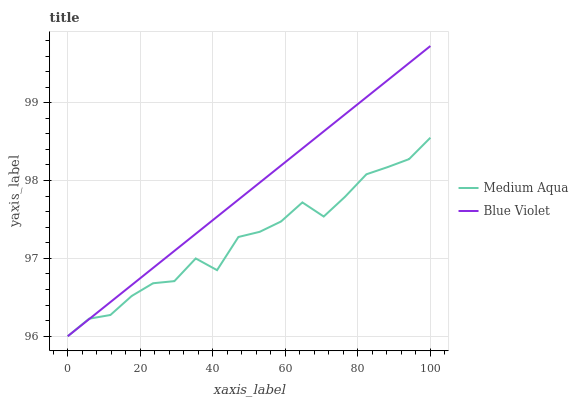Does Medium Aqua have the minimum area under the curve?
Answer yes or no. Yes. Does Blue Violet have the maximum area under the curve?
Answer yes or no. Yes. Does Blue Violet have the minimum area under the curve?
Answer yes or no. No. Is Blue Violet the smoothest?
Answer yes or no. Yes. Is Medium Aqua the roughest?
Answer yes or no. Yes. Is Blue Violet the roughest?
Answer yes or no. No. Does Blue Violet have the highest value?
Answer yes or no. Yes. 